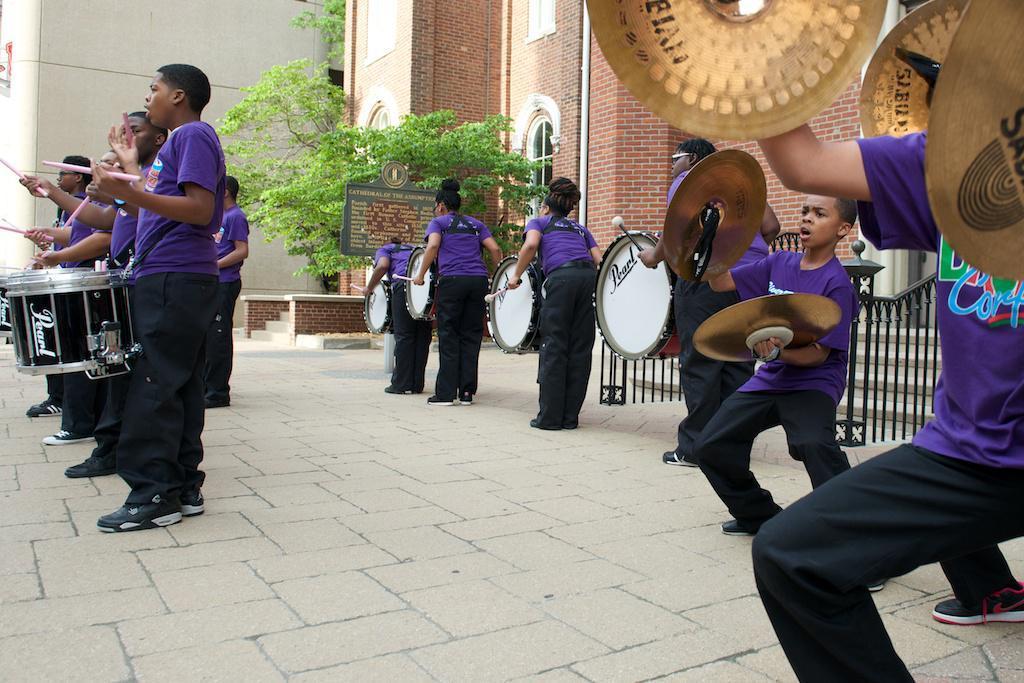Can you describe this image briefly? In this image it seems like group of people who are playing the drums by standing on the floor. To the right side there is a man who is playing the musical plates. In the background there is a tree which is near the building which has windows. 